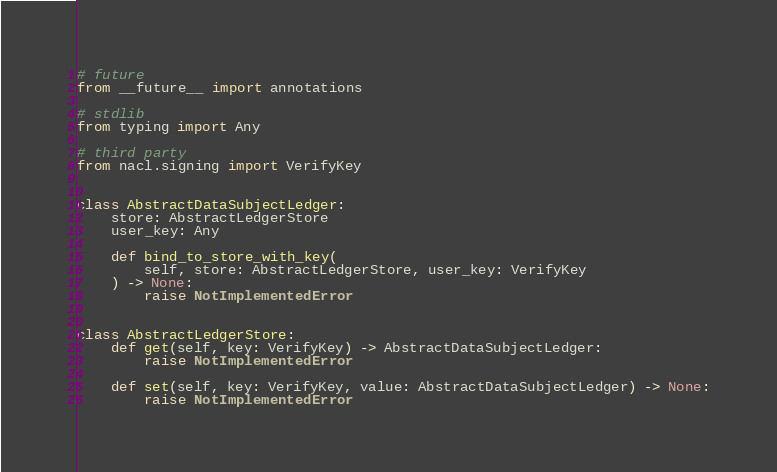<code> <loc_0><loc_0><loc_500><loc_500><_Python_># future
from __future__ import annotations

# stdlib
from typing import Any

# third party
from nacl.signing import VerifyKey


class AbstractDataSubjectLedger:
    store: AbstractLedgerStore
    user_key: Any

    def bind_to_store_with_key(
        self, store: AbstractLedgerStore, user_key: VerifyKey
    ) -> None:
        raise NotImplementedError


class AbstractLedgerStore:
    def get(self, key: VerifyKey) -> AbstractDataSubjectLedger:
        raise NotImplementedError

    def set(self, key: VerifyKey, value: AbstractDataSubjectLedger) -> None:
        raise NotImplementedError
</code> 